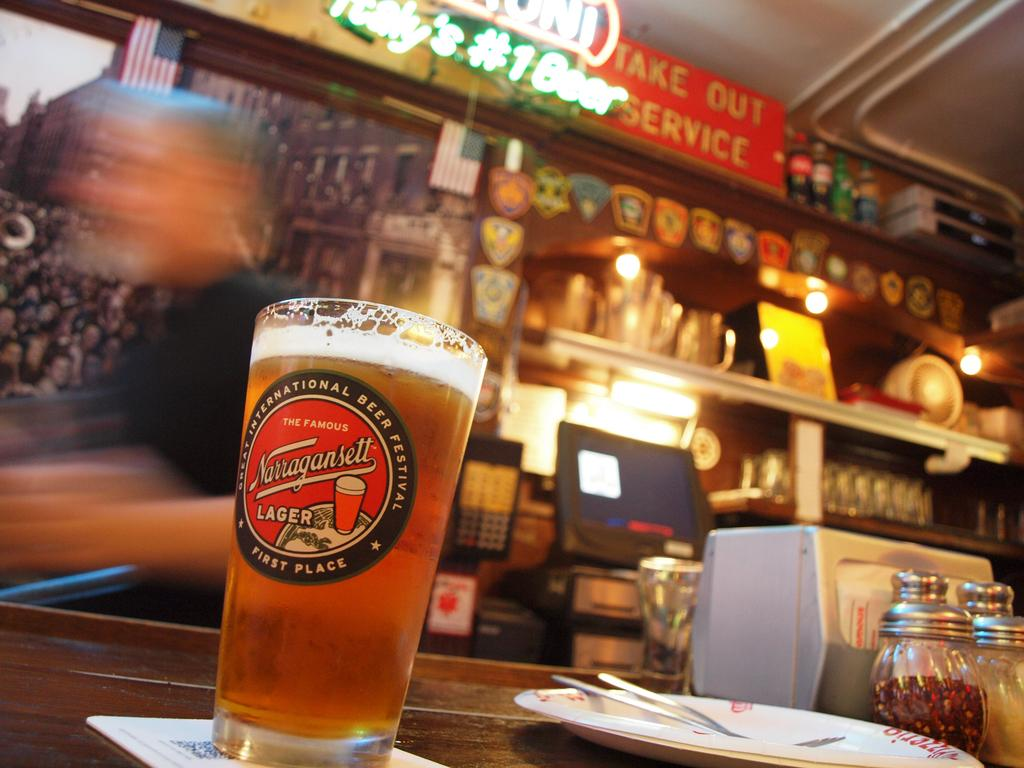<image>
Give a short and clear explanation of the subsequent image. countertop with a full glass of Narragansett lager on it 